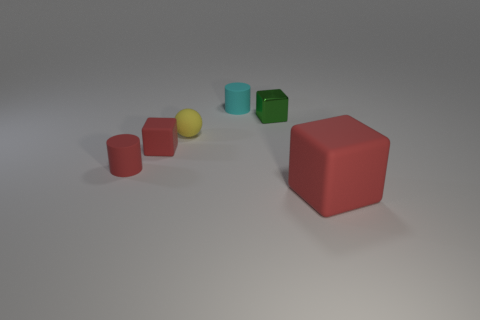Subtract all small green shiny cubes. How many cubes are left? 2 Subtract 1 cylinders. How many cylinders are left? 1 Add 2 tiny red cylinders. How many objects exist? 8 Subtract all blue cubes. How many red spheres are left? 0 Subtract all red rubber cylinders. Subtract all red rubber things. How many objects are left? 2 Add 3 small yellow objects. How many small yellow objects are left? 4 Add 4 yellow rubber objects. How many yellow rubber objects exist? 5 Subtract all green cubes. How many cubes are left? 2 Subtract 0 green balls. How many objects are left? 6 Subtract all cylinders. How many objects are left? 4 